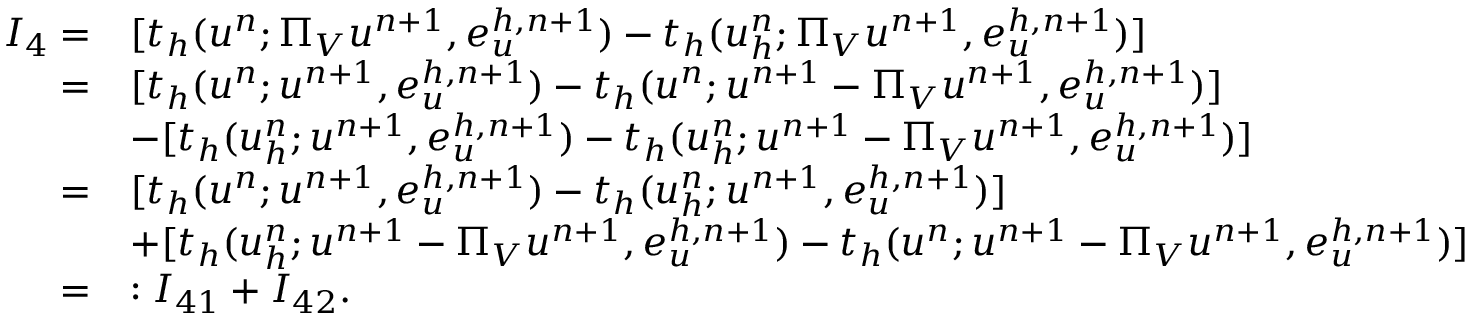<formula> <loc_0><loc_0><loc_500><loc_500>\begin{array} { r l } { I _ { 4 } = } & { [ t _ { h } ( u ^ { n } ; \Pi _ { V } u ^ { n + 1 } , e _ { u } ^ { h , n + 1 } ) - t _ { h } ( u _ { h } ^ { n } ; \Pi _ { V } u ^ { n + 1 } , e _ { u } ^ { h , n + 1 } ) ] } \\ { = } & { [ t _ { h } ( u ^ { n } ; u ^ { n + 1 } , e _ { u } ^ { h , n + 1 } ) - t _ { h } ( u ^ { n } ; u ^ { n + 1 } - \Pi _ { V } u ^ { n + 1 } , e _ { u } ^ { h , n + 1 } ) ] } \\ & { - [ t _ { h } ( u _ { h } ^ { n } ; u ^ { n + 1 } , e _ { u } ^ { h , n + 1 } ) - t _ { h } ( u _ { h } ^ { n } ; u ^ { n + 1 } - \Pi _ { V } u ^ { n + 1 } , e _ { u } ^ { h , n + 1 } ) ] } \\ { = } & { [ t _ { h } ( u ^ { n } ; u ^ { n + 1 } , e _ { u } ^ { h , n + 1 } ) - t _ { h } ( u _ { h } ^ { n } ; u ^ { n + 1 } , e _ { u } ^ { h , n + 1 } ) ] } \\ & { + [ t _ { h } ( u _ { h } ^ { n } ; u ^ { n + 1 } - \Pi _ { V } u ^ { n + 1 } , e _ { u } ^ { h , n + 1 } ) - t _ { h } ( u ^ { n } ; u ^ { n + 1 } - \Pi _ { V } u ^ { n + 1 } , e _ { u } ^ { h , n + 1 } ) ] } \\ { = } & { \colon I _ { 4 1 } + I _ { 4 2 } . } \end{array}</formula> 